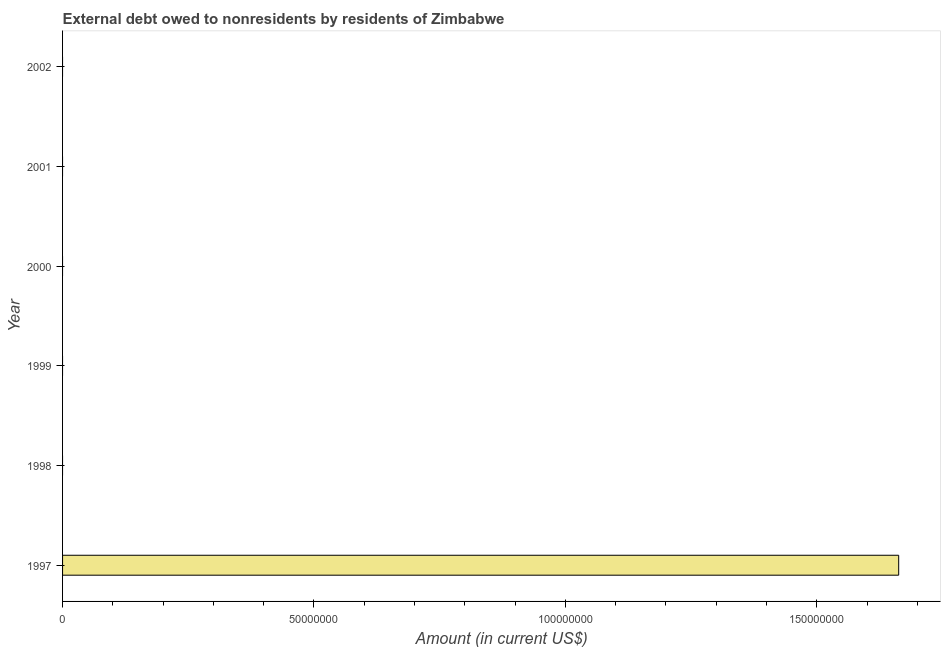Does the graph contain any zero values?
Your response must be concise. Yes. What is the title of the graph?
Provide a succinct answer. External debt owed to nonresidents by residents of Zimbabwe. What is the label or title of the X-axis?
Give a very brief answer. Amount (in current US$). Across all years, what is the maximum debt?
Give a very brief answer. 1.66e+08. Across all years, what is the minimum debt?
Give a very brief answer. 0. What is the sum of the debt?
Offer a very short reply. 1.66e+08. What is the average debt per year?
Ensure brevity in your answer.  2.77e+07. What is the difference between the highest and the lowest debt?
Provide a succinct answer. 1.66e+08. In how many years, is the debt greater than the average debt taken over all years?
Provide a short and direct response. 1. How many bars are there?
Provide a short and direct response. 1. What is the difference between two consecutive major ticks on the X-axis?
Your answer should be very brief. 5.00e+07. What is the Amount (in current US$) in 1997?
Offer a very short reply. 1.66e+08. What is the Amount (in current US$) in 1999?
Provide a succinct answer. 0. What is the Amount (in current US$) in 2000?
Offer a terse response. 0. What is the Amount (in current US$) of 2001?
Give a very brief answer. 0. 